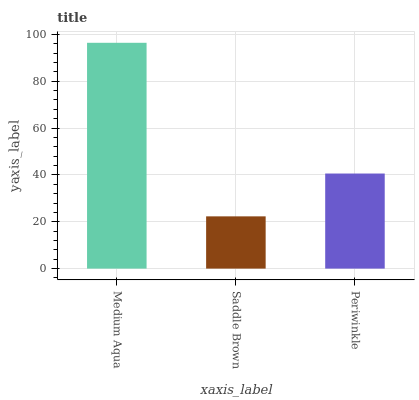Is Saddle Brown the minimum?
Answer yes or no. Yes. Is Medium Aqua the maximum?
Answer yes or no. Yes. Is Periwinkle the minimum?
Answer yes or no. No. Is Periwinkle the maximum?
Answer yes or no. No. Is Periwinkle greater than Saddle Brown?
Answer yes or no. Yes. Is Saddle Brown less than Periwinkle?
Answer yes or no. Yes. Is Saddle Brown greater than Periwinkle?
Answer yes or no. No. Is Periwinkle less than Saddle Brown?
Answer yes or no. No. Is Periwinkle the high median?
Answer yes or no. Yes. Is Periwinkle the low median?
Answer yes or no. Yes. Is Medium Aqua the high median?
Answer yes or no. No. Is Saddle Brown the low median?
Answer yes or no. No. 